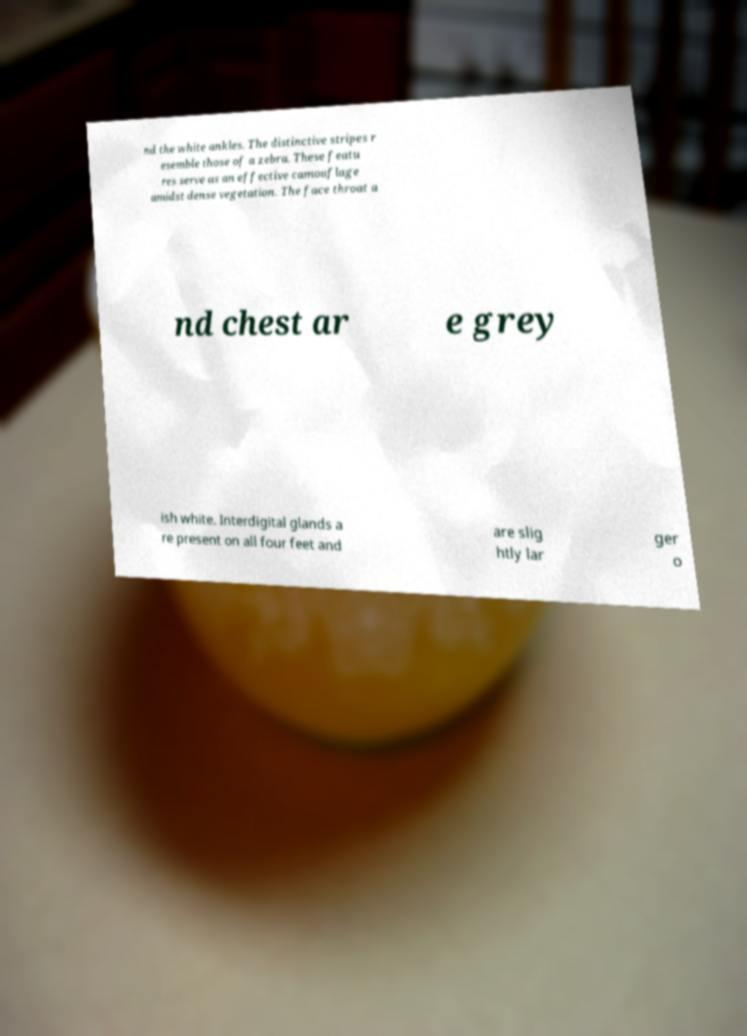What messages or text are displayed in this image? I need them in a readable, typed format. nd the white ankles. The distinctive stripes r esemble those of a zebra. These featu res serve as an effective camouflage amidst dense vegetation. The face throat a nd chest ar e grey ish white. Interdigital glands a re present on all four feet and are slig htly lar ger o 